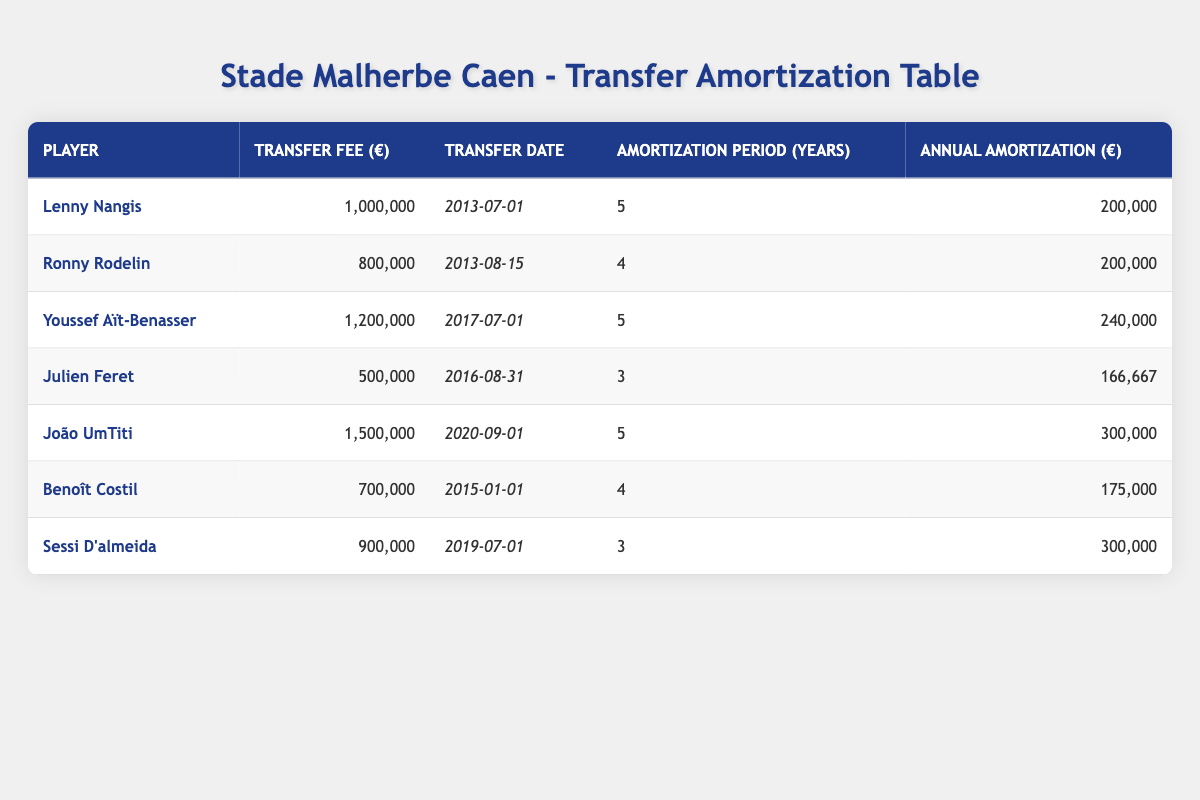What was the transfer fee for Lenny Nangis? The table lists the transfer fee for Lenny Nangis in the second row under the "Transfer Fee (€)" column, which is 1,000,000.
Answer: 1,000,000 How many years was the amortization period for Youssef Aït-Benasser? In the row for Youssef Aït-Benasser, the amortization period in the "Amortization Period (Years)" column is 5.
Answer: 5 Is the annual amortization for João UmTiti higher than that for Sessi D'almeida? The annual amortization for João UmTiti is 300,000 and for Sessi D'almeida it is also 300,000, which means they are equal. Therefore, the statement is false.
Answer: No What is the total transfer fee paid for all players listed in the table? To find the total transfer fee, sum all transfer fees: 1,000,000 + 800,000 + 1,200,000 + 500,000 + 1,500,000 + 700,000 + 900,000 = 6,600,000.
Answer: 6,600,000 What is the average annual amortization of all players in the table? Calculate the annual amortization for each player: 200,000, 200,000, 240,000, 166,667, 300,000, 175,000, and 300,000. Sum these values: (200,000 + 200,000 + 240,000 + 166,667 + 300,000 + 175,000 + 300,000) = 1,581,667. Divide by the number of players (7) to get the average: 1,581,667 / 7 ≈ 225,524.
Answer: 225,524 Was the transfer date of Julien Feret before that of Benoît Costil? Julien Feret's transfer date is 2016-08-31 and Benoît Costil's is 2015-01-01. Since 2016 is after 2015, the statement is false.
Answer: No How many players had an amortization period of 5 years? Looking at the "Amortization Period (Years)" column, Lenny Nangis, Youssef Aït-Benasser, and João UmTiti all had 5 years as their amortization period. Therefore, there are 3 players.
Answer: 3 What player had the lowest transfer fee paid by Stade Malherbe Caen over the last decade? The lowest transfer fee from the "Transfer Fee (€)" column is 500,000, which corresponds to Julien Feret listed in the table.
Answer: Julien Feret 